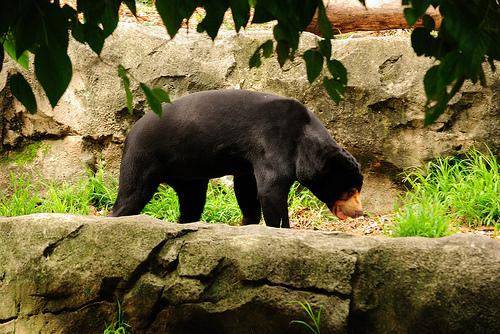Question: what animal is pictured?
Choices:
A. A bear.
B. A raccoon.
C. A badger.
D. A wolf.
Answer with the letter. Answer: A Question: who is feeding the bear?
Choices:
A. 1 person.
B. 2 people.
C. Nobody.
D. 3 people.
Answer with the letter. Answer: C Question: when was the picture taken?
Choices:
A. At dawn.
B. During the daytime.
C. At twilight.
D. At night.
Answer with the letter. Answer: B Question: where was the picture probably taken?
Choices:
A. At the park.
B. In the woods.
C. At the zoo.
D. In the ocean.
Answer with the letter. Answer: C Question: what color ar the plants and tree leaves?
Choices:
A. Green.
B. Brown.
C. Orange.
D. Red.
Answer with the letter. Answer: A 